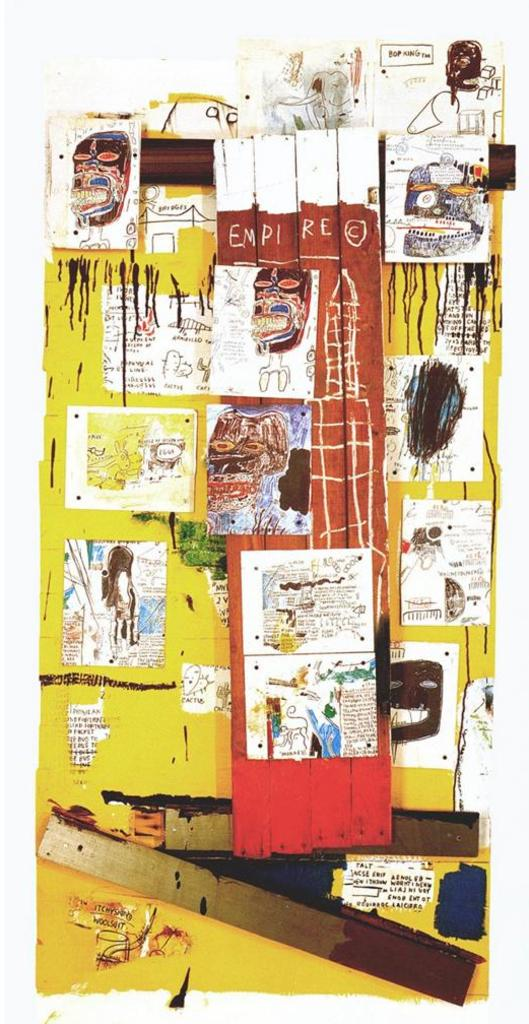What is the main subject of the image? There is an artwork in the image. What color is the artwork? The artwork is in yellow color. What can be seen within the artwork? There are images in the artwork. Can you see the face of the person pulling the branch in the artwork? There is no person or branch present in the artwork; it only consists of images in yellow color. 